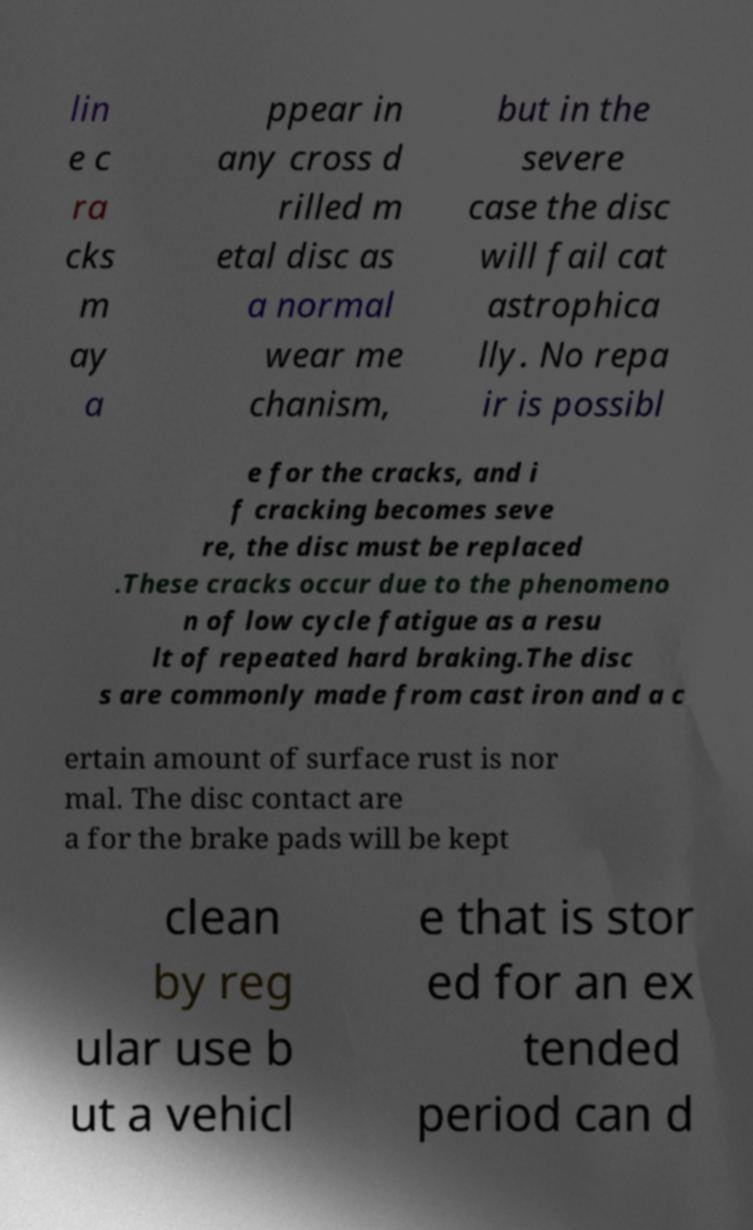Please identify and transcribe the text found in this image. lin e c ra cks m ay a ppear in any cross d rilled m etal disc as a normal wear me chanism, but in the severe case the disc will fail cat astrophica lly. No repa ir is possibl e for the cracks, and i f cracking becomes seve re, the disc must be replaced .These cracks occur due to the phenomeno n of low cycle fatigue as a resu lt of repeated hard braking.The disc s are commonly made from cast iron and a c ertain amount of surface rust is nor mal. The disc contact are a for the brake pads will be kept clean by reg ular use b ut a vehicl e that is stor ed for an ex tended period can d 